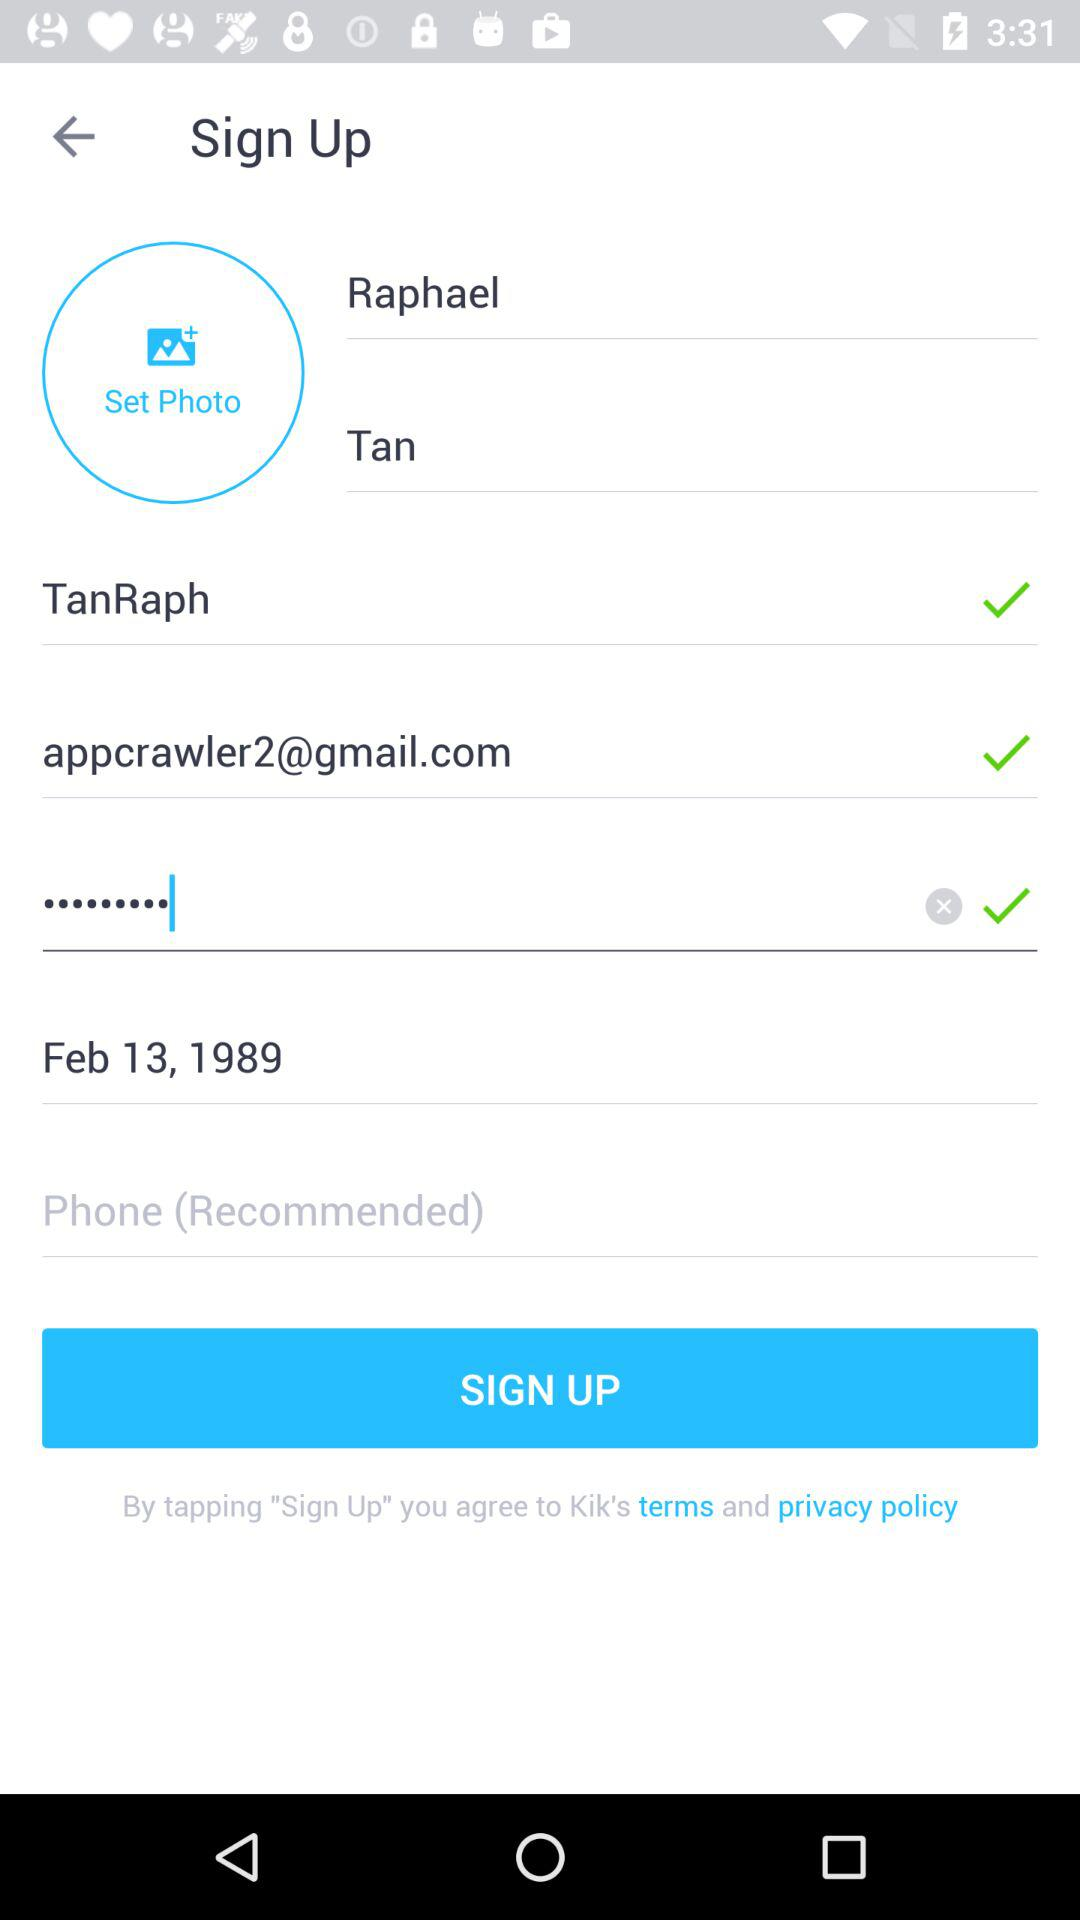What is the name of the user? The name of the user is Raphael Tan. 